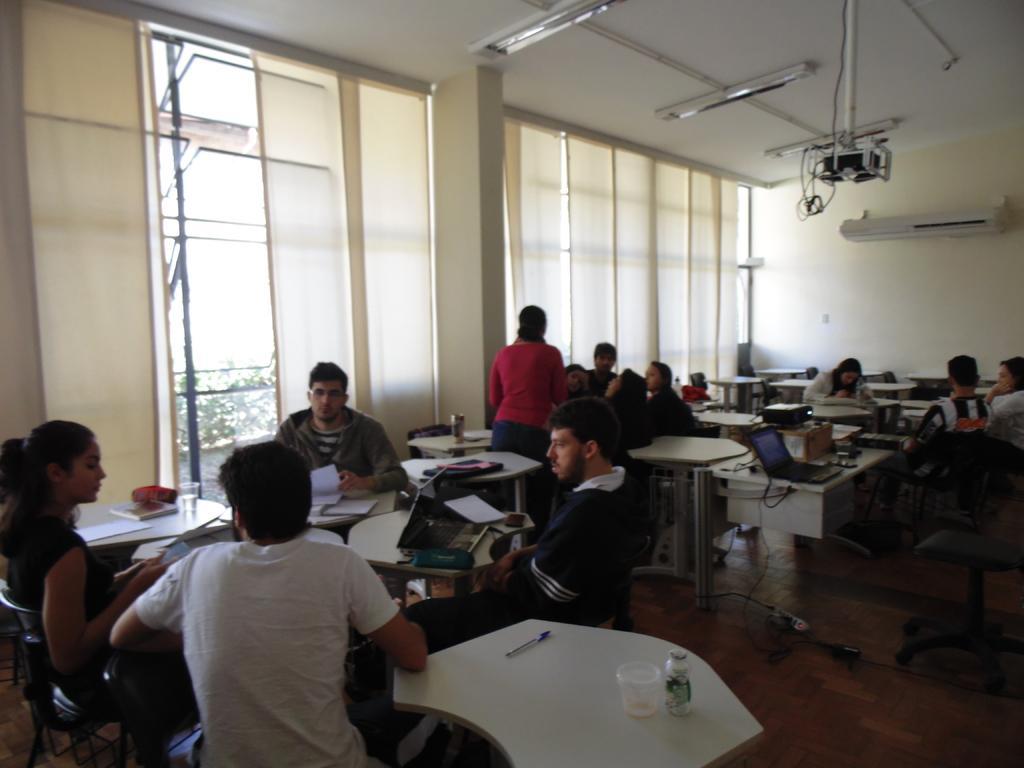Can you describe this image briefly? There are group of men and women with books in their hand and laptop in their front on table. There is projector extension pole to the ceiling and lights. The window have curtain outside the window there is tree visible. 